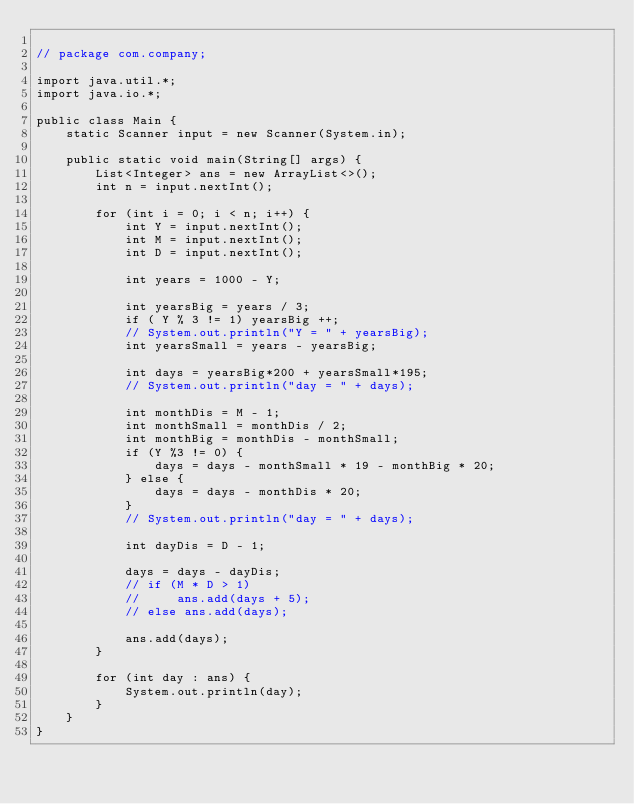Convert code to text. <code><loc_0><loc_0><loc_500><loc_500><_Java_>
// package com.company;

import java.util.*;
import java.io.*;

public class Main {
    static Scanner input = new Scanner(System.in);

    public static void main(String[] args) {
        List<Integer> ans = new ArrayList<>();
        int n = input.nextInt();

        for (int i = 0; i < n; i++) {
            int Y = input.nextInt();
            int M = input.nextInt();
            int D = input.nextInt();

            int years = 1000 - Y;

            int yearsBig = years / 3;
            if ( Y % 3 != 1) yearsBig ++;
            // System.out.println("Y = " + yearsBig);
            int yearsSmall = years - yearsBig;

            int days = yearsBig*200 + yearsSmall*195;
            // System.out.println("day = " + days);

            int monthDis = M - 1;
            int monthSmall = monthDis / 2;
            int monthBig = monthDis - monthSmall;
            if (Y %3 != 0) {
                days = days - monthSmall * 19 - monthBig * 20;
            } else {
                days = days - monthDis * 20;
            }
            // System.out.println("day = " + days);

            int dayDis = D - 1;

            days = days - dayDis;
            // if (M * D > 1)
            //     ans.add(days + 5);
            // else ans.add(days);

            ans.add(days);
        }

        for (int day : ans) {
            System.out.println(day);
        }
    }
}
</code> 